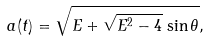Convert formula to latex. <formula><loc_0><loc_0><loc_500><loc_500>a ( t ) = \sqrt { E + \sqrt { E ^ { 2 } - 4 } \, \sin \theta } ,</formula> 